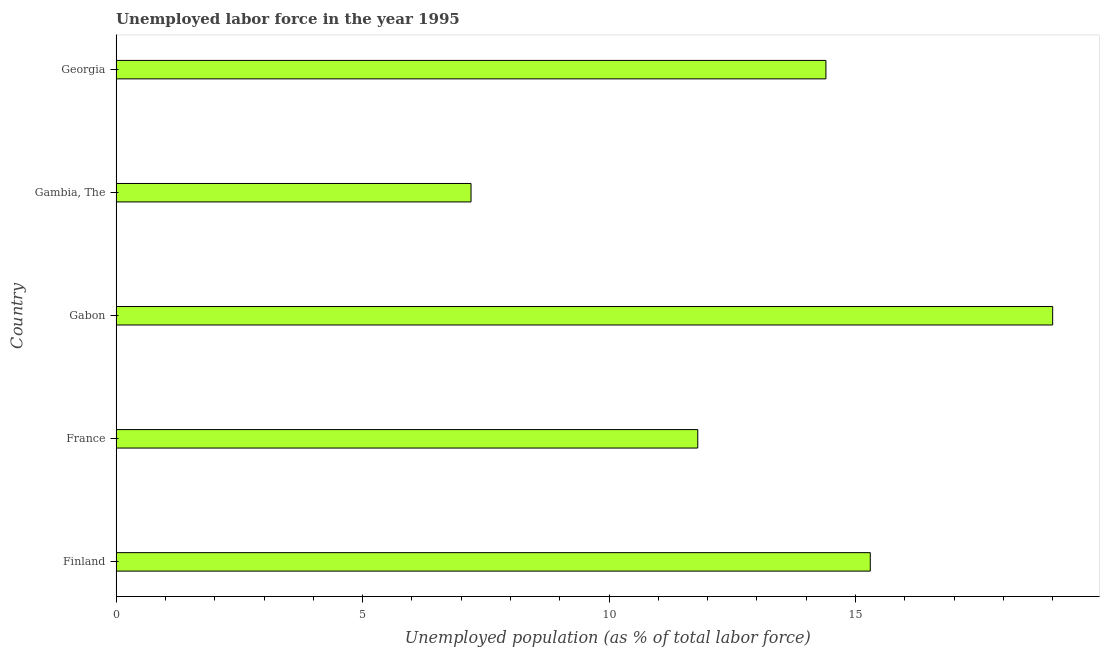Does the graph contain any zero values?
Offer a very short reply. No. What is the title of the graph?
Provide a succinct answer. Unemployed labor force in the year 1995. What is the label or title of the X-axis?
Ensure brevity in your answer.  Unemployed population (as % of total labor force). What is the total unemployed population in France?
Ensure brevity in your answer.  11.8. Across all countries, what is the maximum total unemployed population?
Your answer should be very brief. 19. Across all countries, what is the minimum total unemployed population?
Provide a succinct answer. 7.2. In which country was the total unemployed population maximum?
Make the answer very short. Gabon. In which country was the total unemployed population minimum?
Offer a very short reply. Gambia, The. What is the sum of the total unemployed population?
Your answer should be compact. 67.7. What is the average total unemployed population per country?
Offer a terse response. 13.54. What is the median total unemployed population?
Keep it short and to the point. 14.4. What is the ratio of the total unemployed population in Finland to that in Gambia, The?
Offer a terse response. 2.12. Is the total unemployed population in Finland less than that in Georgia?
Make the answer very short. No. Is the difference between the total unemployed population in Gambia, The and Georgia greater than the difference between any two countries?
Provide a succinct answer. No. Is the sum of the total unemployed population in France and Gambia, The greater than the maximum total unemployed population across all countries?
Provide a succinct answer. Yes. What is the difference between the highest and the lowest total unemployed population?
Your response must be concise. 11.8. How many bars are there?
Give a very brief answer. 5. How many countries are there in the graph?
Your response must be concise. 5. What is the difference between two consecutive major ticks on the X-axis?
Offer a terse response. 5. What is the Unemployed population (as % of total labor force) in Finland?
Keep it short and to the point. 15.3. What is the Unemployed population (as % of total labor force) of France?
Provide a short and direct response. 11.8. What is the Unemployed population (as % of total labor force) in Gambia, The?
Your response must be concise. 7.2. What is the Unemployed population (as % of total labor force) in Georgia?
Your answer should be compact. 14.4. What is the difference between the Unemployed population (as % of total labor force) in Finland and France?
Your answer should be very brief. 3.5. What is the difference between the Unemployed population (as % of total labor force) in Finland and Gambia, The?
Offer a very short reply. 8.1. What is the difference between the Unemployed population (as % of total labor force) in Finland and Georgia?
Give a very brief answer. 0.9. What is the difference between the Unemployed population (as % of total labor force) in France and Gabon?
Your response must be concise. -7.2. What is the difference between the Unemployed population (as % of total labor force) in France and Gambia, The?
Your answer should be very brief. 4.6. What is the difference between the Unemployed population (as % of total labor force) in France and Georgia?
Make the answer very short. -2.6. What is the difference between the Unemployed population (as % of total labor force) in Gabon and Gambia, The?
Offer a terse response. 11.8. What is the difference between the Unemployed population (as % of total labor force) in Gabon and Georgia?
Offer a very short reply. 4.6. What is the difference between the Unemployed population (as % of total labor force) in Gambia, The and Georgia?
Offer a very short reply. -7.2. What is the ratio of the Unemployed population (as % of total labor force) in Finland to that in France?
Ensure brevity in your answer.  1.3. What is the ratio of the Unemployed population (as % of total labor force) in Finland to that in Gabon?
Provide a short and direct response. 0.81. What is the ratio of the Unemployed population (as % of total labor force) in Finland to that in Gambia, The?
Your answer should be compact. 2.12. What is the ratio of the Unemployed population (as % of total labor force) in Finland to that in Georgia?
Give a very brief answer. 1.06. What is the ratio of the Unemployed population (as % of total labor force) in France to that in Gabon?
Provide a succinct answer. 0.62. What is the ratio of the Unemployed population (as % of total labor force) in France to that in Gambia, The?
Provide a short and direct response. 1.64. What is the ratio of the Unemployed population (as % of total labor force) in France to that in Georgia?
Give a very brief answer. 0.82. What is the ratio of the Unemployed population (as % of total labor force) in Gabon to that in Gambia, The?
Provide a short and direct response. 2.64. What is the ratio of the Unemployed population (as % of total labor force) in Gabon to that in Georgia?
Your answer should be very brief. 1.32. What is the ratio of the Unemployed population (as % of total labor force) in Gambia, The to that in Georgia?
Your response must be concise. 0.5. 